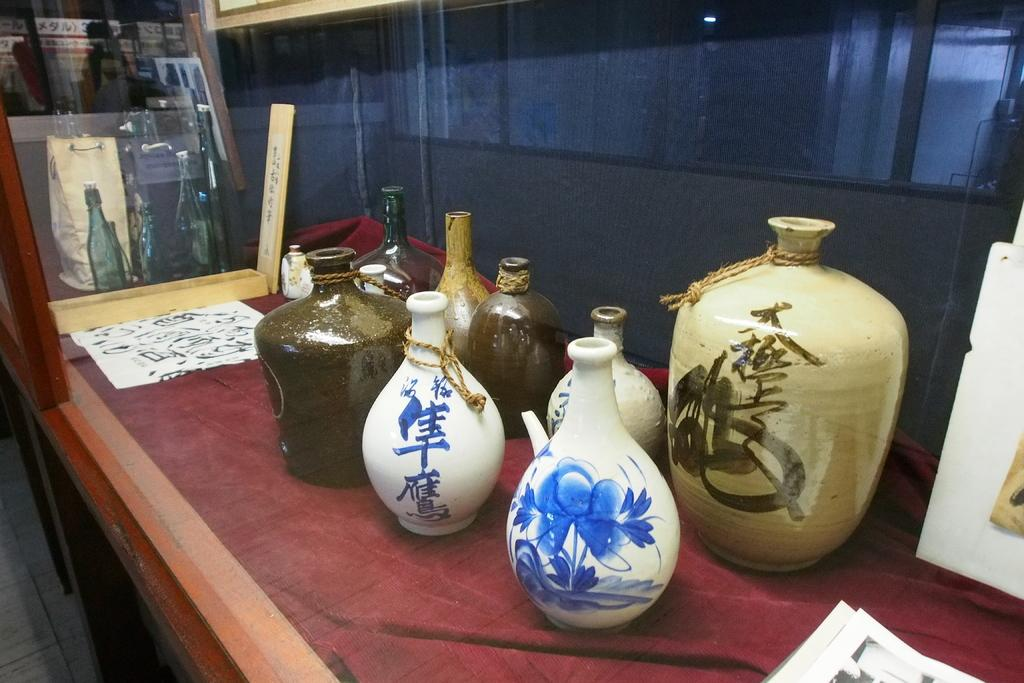What objects are on the table in the image? There are painted pots on a table in the image. What else can be seen in the image besides the painted pots? There are papers in the image. Can you describe any other visual effects in the image? There is a reflection of the pots on a glass in the image. What type of cake is being sliced in the image? There is no cake present in the image; it features painted pots on a table. Can you tell me how many rifles are visible in the image? There are no rifles present in the image. 